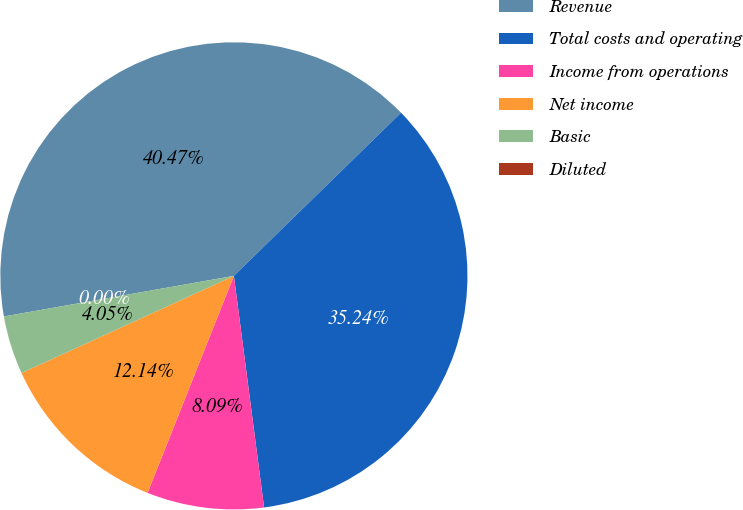Convert chart. <chart><loc_0><loc_0><loc_500><loc_500><pie_chart><fcel>Revenue<fcel>Total costs and operating<fcel>Income from operations<fcel>Net income<fcel>Basic<fcel>Diluted<nl><fcel>40.47%<fcel>35.24%<fcel>8.09%<fcel>12.14%<fcel>4.05%<fcel>0.0%<nl></chart> 